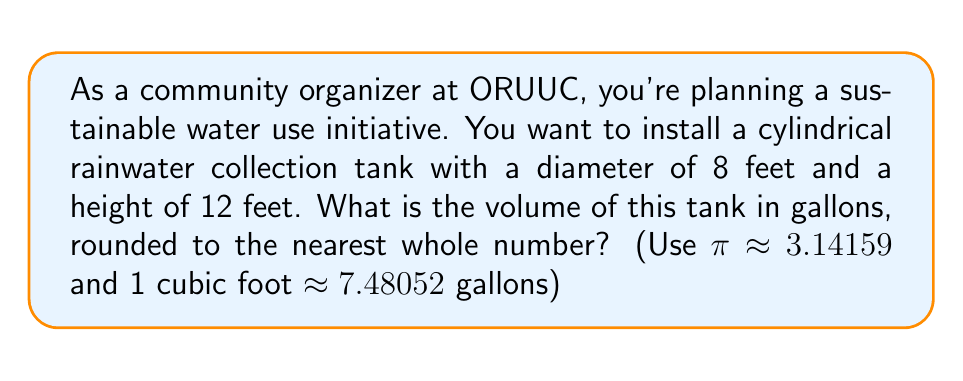What is the answer to this math problem? To solve this problem, we'll follow these steps:

1. Calculate the volume of the cylindrical tank in cubic feet.
2. Convert the volume from cubic feet to gallons.
3. Round the result to the nearest whole number.

Step 1: Calculate the volume of the cylinder

The volume of a cylinder is given by the formula:

$$V = \pi r^2 h$$

Where:
$r$ is the radius of the base
$h$ is the height of the cylinder

Given:
Diameter = 8 feet, so radius = 4 feet
Height = 12 feet
π ≈ 3.14159

Substituting these values:

$$V = 3.14159 \times 4^2 \times 12$$
$$V = 3.14159 \times 16 \times 12$$
$$V = 603.18528 \text{ cubic feet}$$

Step 2: Convert cubic feet to gallons

We're given that 1 cubic foot ≈ 7.48052 gallons

So, we multiply our volume by this conversion factor:

$$603.18528 \times 7.48052 = 4512.11850656 \text{ gallons}$$

Step 3: Round to the nearest whole number

4512.11850656 rounds to 4512 gallons.
Answer: 4512 gallons 